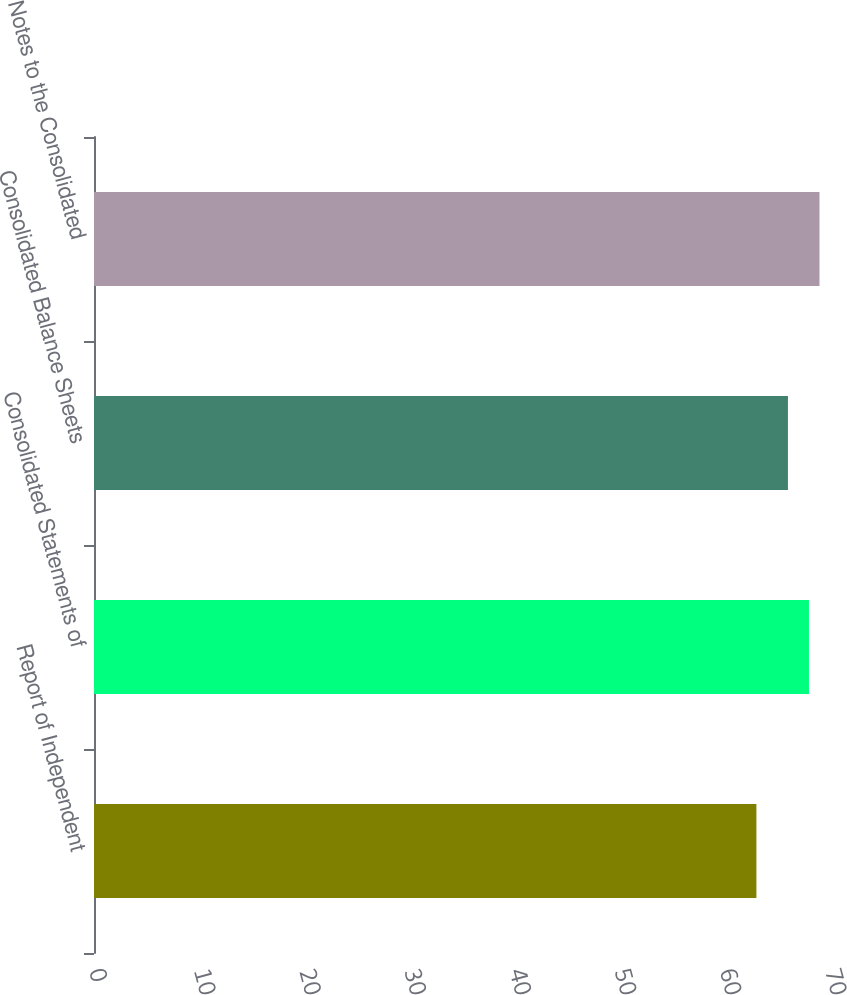Convert chart to OTSL. <chart><loc_0><loc_0><loc_500><loc_500><bar_chart><fcel>Report of Independent<fcel>Consolidated Statements of<fcel>Consolidated Balance Sheets<fcel>Notes to the Consolidated<nl><fcel>63<fcel>68<fcel>66<fcel>69<nl></chart> 